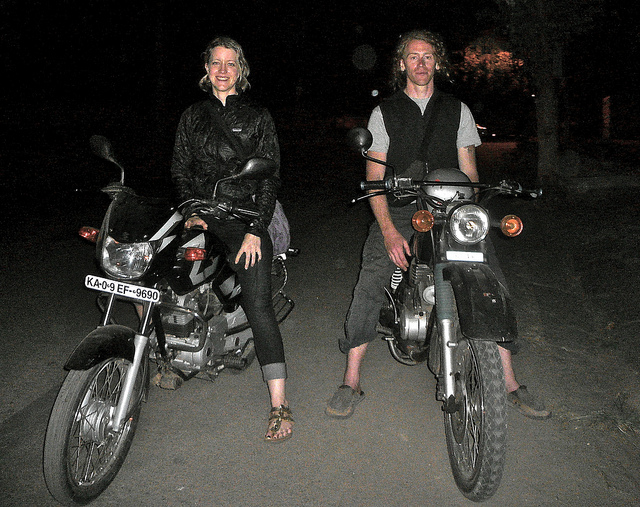What are the makes and models of the motorcycles? Based on the image, I can see one motorcycle with visible alphanumeric characters 'KA-09-EF-9690', but without clearer branding details, I'm unable to accurately determine the specific makes and models of the motorcycles. 